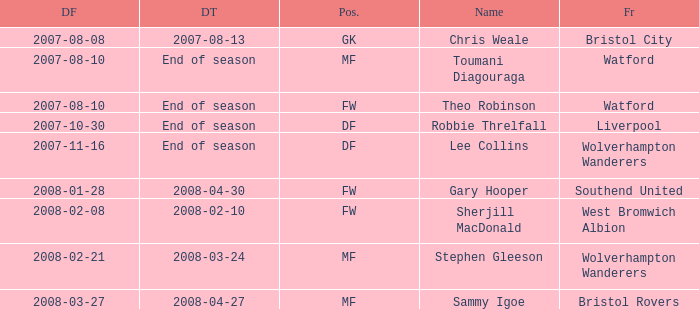What was the from for the Date From of 2007-08-08? Bristol City. 